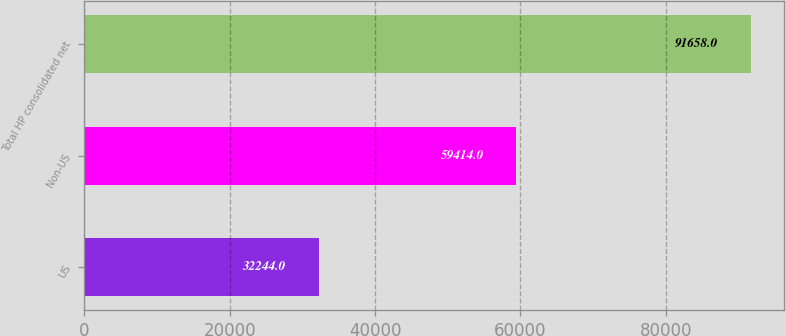Convert chart to OTSL. <chart><loc_0><loc_0><loc_500><loc_500><bar_chart><fcel>US<fcel>Non-US<fcel>Total HP consolidated net<nl><fcel>32244<fcel>59414<fcel>91658<nl></chart> 